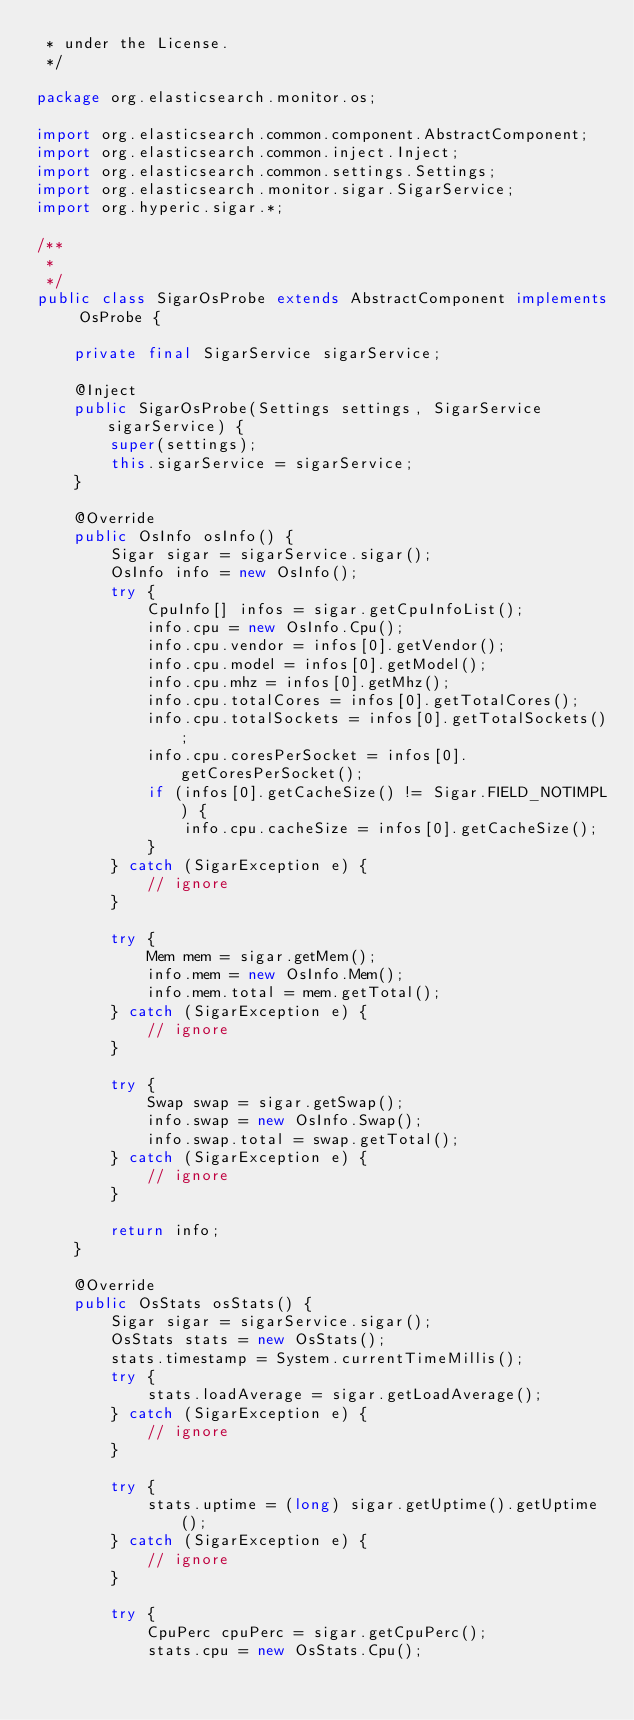<code> <loc_0><loc_0><loc_500><loc_500><_Java_> * under the License.
 */

package org.elasticsearch.monitor.os;

import org.elasticsearch.common.component.AbstractComponent;
import org.elasticsearch.common.inject.Inject;
import org.elasticsearch.common.settings.Settings;
import org.elasticsearch.monitor.sigar.SigarService;
import org.hyperic.sigar.*;

/**
 *
 */
public class SigarOsProbe extends AbstractComponent implements OsProbe {

    private final SigarService sigarService;

    @Inject
    public SigarOsProbe(Settings settings, SigarService sigarService) {
        super(settings);
        this.sigarService = sigarService;
    }

    @Override
    public OsInfo osInfo() {
        Sigar sigar = sigarService.sigar();
        OsInfo info = new OsInfo();
        try {
            CpuInfo[] infos = sigar.getCpuInfoList();
            info.cpu = new OsInfo.Cpu();
            info.cpu.vendor = infos[0].getVendor();
            info.cpu.model = infos[0].getModel();
            info.cpu.mhz = infos[0].getMhz();
            info.cpu.totalCores = infos[0].getTotalCores();
            info.cpu.totalSockets = infos[0].getTotalSockets();
            info.cpu.coresPerSocket = infos[0].getCoresPerSocket();
            if (infos[0].getCacheSize() != Sigar.FIELD_NOTIMPL) {
                info.cpu.cacheSize = infos[0].getCacheSize();
            }
        } catch (SigarException e) {
            // ignore
        }

        try {
            Mem mem = sigar.getMem();
            info.mem = new OsInfo.Mem();
            info.mem.total = mem.getTotal();
        } catch (SigarException e) {
            // ignore
        }

        try {
            Swap swap = sigar.getSwap();
            info.swap = new OsInfo.Swap();
            info.swap.total = swap.getTotal();
        } catch (SigarException e) {
            // ignore
        }

        return info;
    }

    @Override
    public OsStats osStats() {
        Sigar sigar = sigarService.sigar();
        OsStats stats = new OsStats();
        stats.timestamp = System.currentTimeMillis();
        try {
            stats.loadAverage = sigar.getLoadAverage();
        } catch (SigarException e) {
            // ignore
        }

        try {
            stats.uptime = (long) sigar.getUptime().getUptime();
        } catch (SigarException e) {
            // ignore
        }

        try {
            CpuPerc cpuPerc = sigar.getCpuPerc();
            stats.cpu = new OsStats.Cpu();</code> 